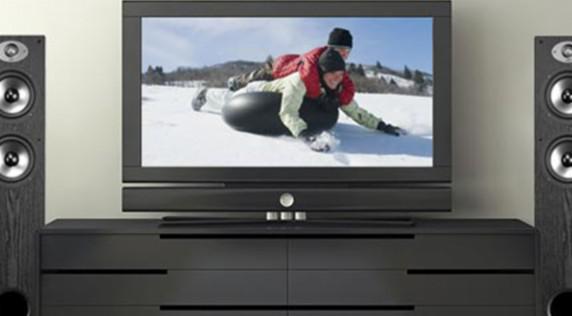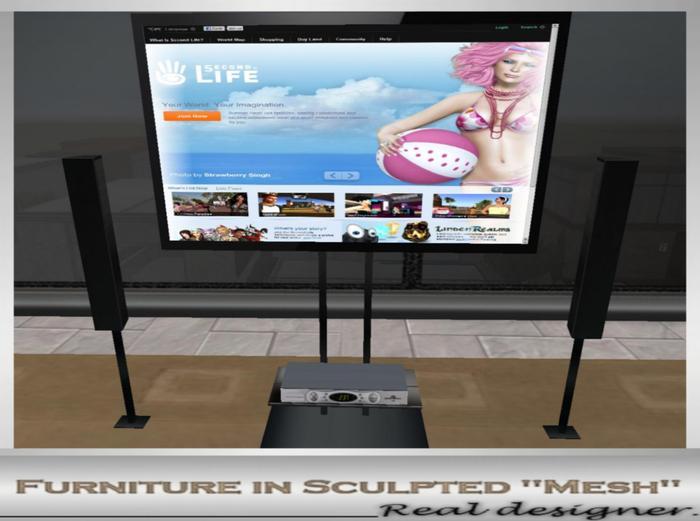The first image is the image on the left, the second image is the image on the right. Evaluate the accuracy of this statement regarding the images: "There are two people on the television on the left.". Is it true? Answer yes or no. Yes. 